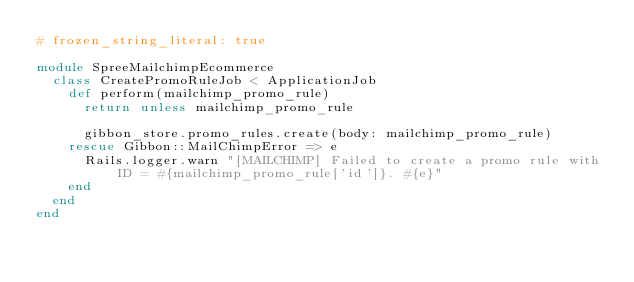Convert code to text. <code><loc_0><loc_0><loc_500><loc_500><_Ruby_># frozen_string_literal: true

module SpreeMailchimpEcommerce
  class CreatePromoRuleJob < ApplicationJob
    def perform(mailchimp_promo_rule)
      return unless mailchimp_promo_rule

      gibbon_store.promo_rules.create(body: mailchimp_promo_rule)
    rescue Gibbon::MailChimpError => e
      Rails.logger.warn "[MAILCHIMP] Failed to create a promo rule with ID = #{mailchimp_promo_rule['id']}. #{e}"
    end
  end
end
</code> 